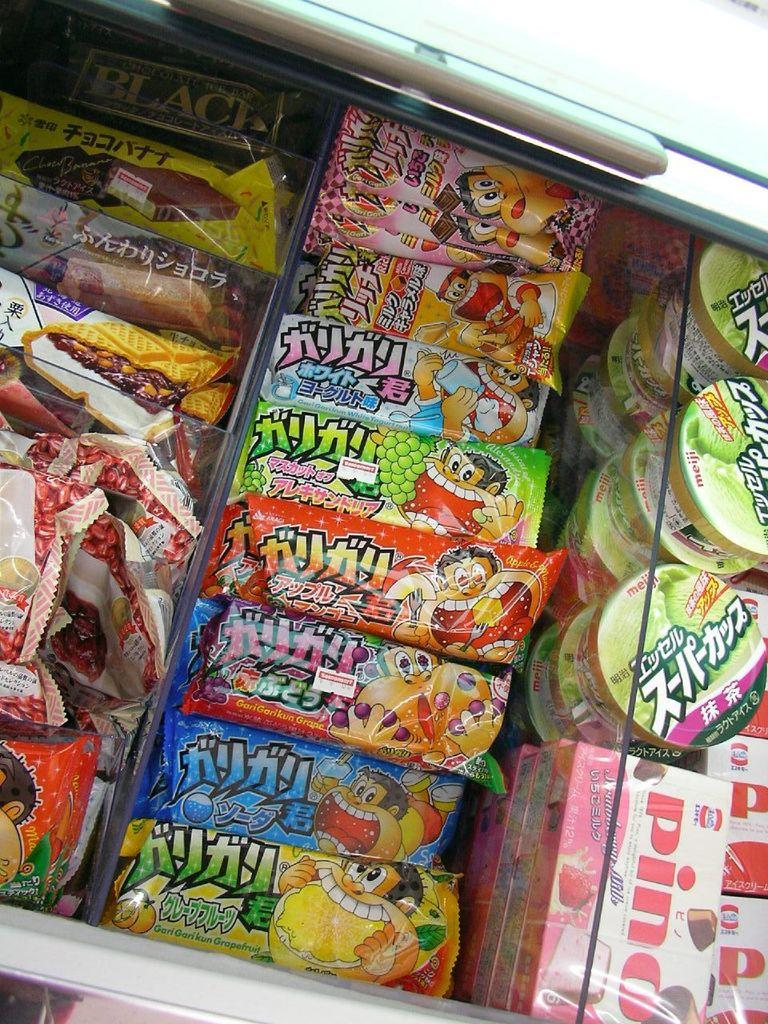<image>
Describe the image concisely. Many snacks for sale in a freezer including one named Pino. 